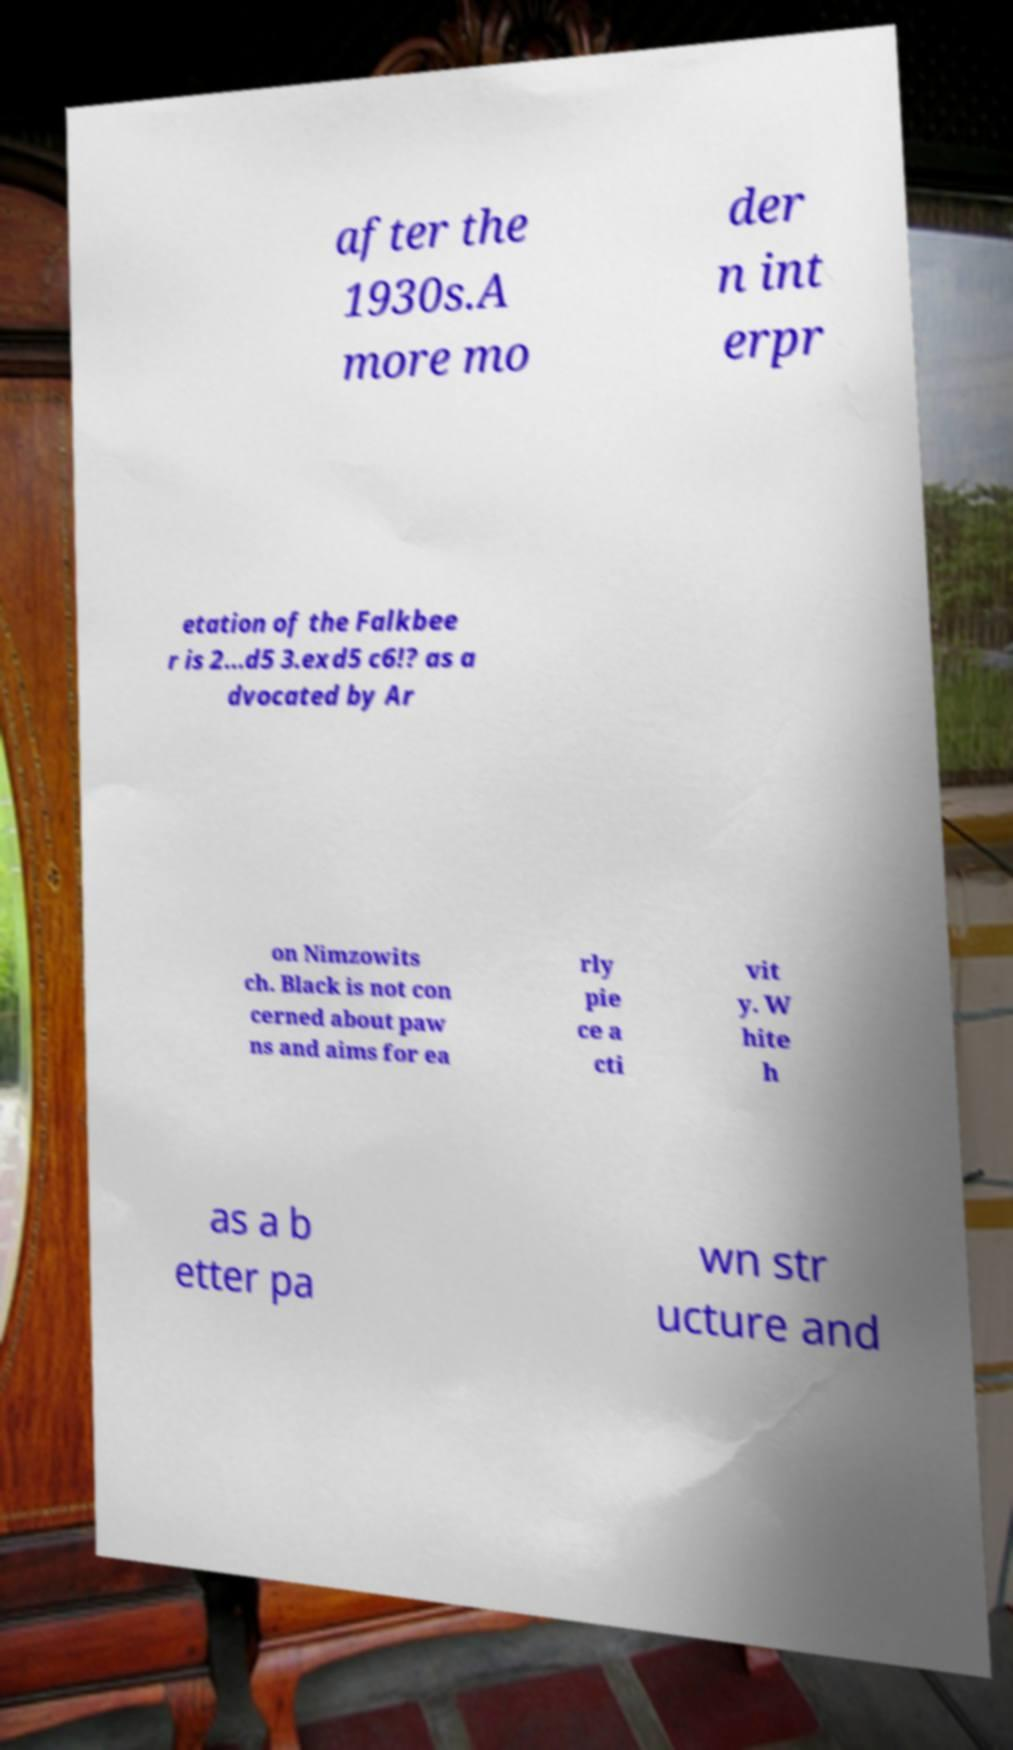Could you extract and type out the text from this image? after the 1930s.A more mo der n int erpr etation of the Falkbee r is 2...d5 3.exd5 c6!? as a dvocated by Ar on Nimzowits ch. Black is not con cerned about paw ns and aims for ea rly pie ce a cti vit y. W hite h as a b etter pa wn str ucture and 